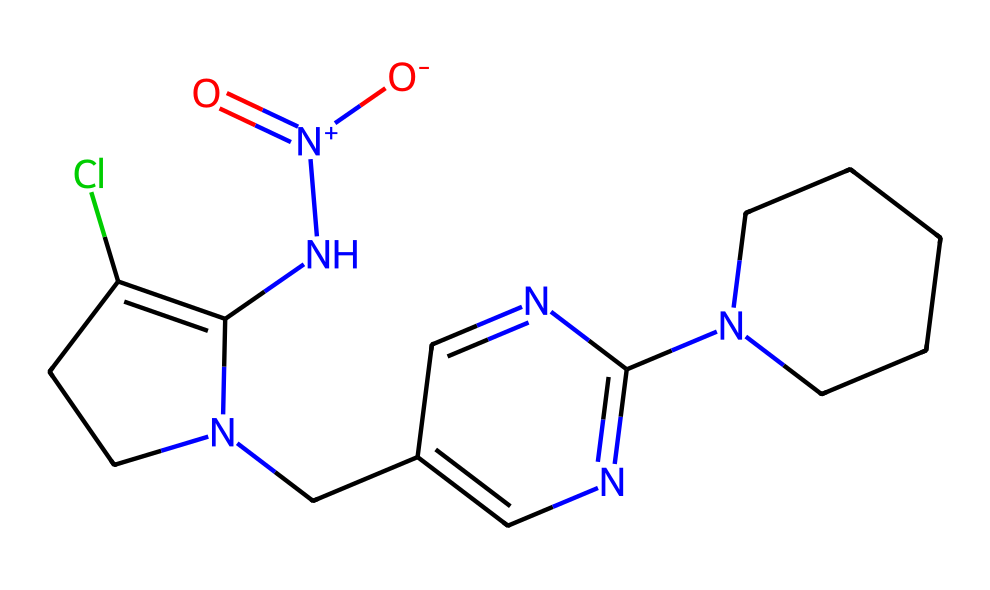What is the main functional group in imidacloprid? The main functional group in imidacloprid is the nitro group, which is indicated by the presence of a nitrogen atom connected to two oxygen atoms with one of them being double-bonded, represented as N(=O)(=O).
Answer: nitro group How many rings are present in the chemical structure of imidacloprid? By analyzing the SMILES representation, we can identify the presence of two distinct cyclic structures labeled by the numbers 1 and 2 in the SMILES, indicating the formation of two rings in the molecule.
Answer: two What is the molecular formula of imidacloprid based on its structure? To derive the molecular formula from the SMILES representation, we identify the counts of different atoms: nitrogen (N), carbon (C), hydrogen (H), oxygen (O), and chlorine (Cl). Count yields C10H14ClN5O2.
Answer: C10H14ClN5O2 What type of pesticide class does imidacloprid belong to? Imidacloprid is part of the neonicotinoids class, which is indicated by its structural similarity to nicotine and the presence of the nitrogen-containing aromatic rings in its structure.
Answer: neonicotinoids Which atoms in imidacloprid are responsible for its activity as an insecticide? The nitrogen atoms and the binding rings in imidacloprid structure contribute to its mechanism of action as an insecticide, especially the presence of the nitro group and the cyclic structures that facilitate interaction with insect nervous systems.
Answer: nitrogen atoms How many nitrogen atoms are found in imidacloprid? By examining the SMILES, we can count a total of five nitrogen atoms present in the structure, as each N in the representation corresponds to a distinct nitrogen atom.
Answer: five 